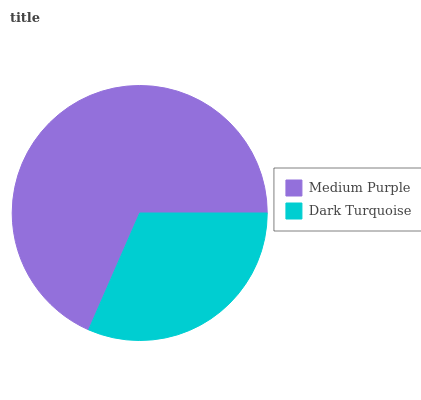Is Dark Turquoise the minimum?
Answer yes or no. Yes. Is Medium Purple the maximum?
Answer yes or no. Yes. Is Dark Turquoise the maximum?
Answer yes or no. No. Is Medium Purple greater than Dark Turquoise?
Answer yes or no. Yes. Is Dark Turquoise less than Medium Purple?
Answer yes or no. Yes. Is Dark Turquoise greater than Medium Purple?
Answer yes or no. No. Is Medium Purple less than Dark Turquoise?
Answer yes or no. No. Is Medium Purple the high median?
Answer yes or no. Yes. Is Dark Turquoise the low median?
Answer yes or no. Yes. Is Dark Turquoise the high median?
Answer yes or no. No. Is Medium Purple the low median?
Answer yes or no. No. 